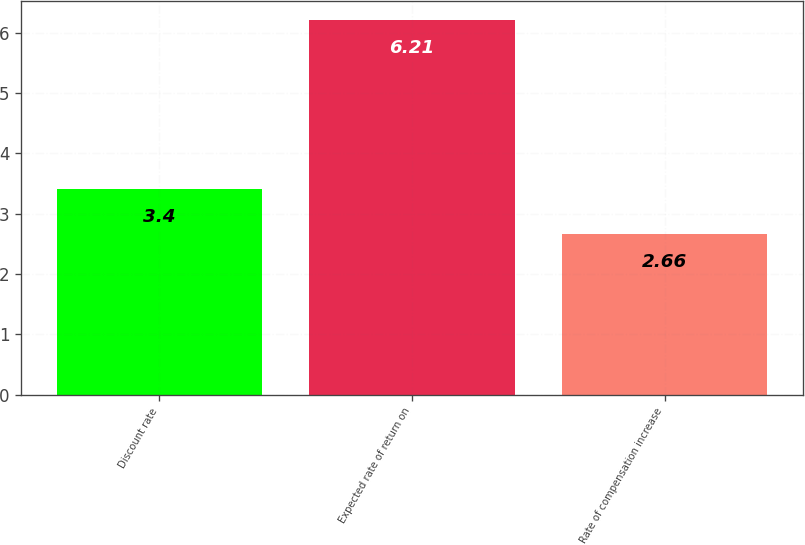Convert chart to OTSL. <chart><loc_0><loc_0><loc_500><loc_500><bar_chart><fcel>Discount rate<fcel>Expected rate of return on<fcel>Rate of compensation increase<nl><fcel>3.4<fcel>6.21<fcel>2.66<nl></chart> 